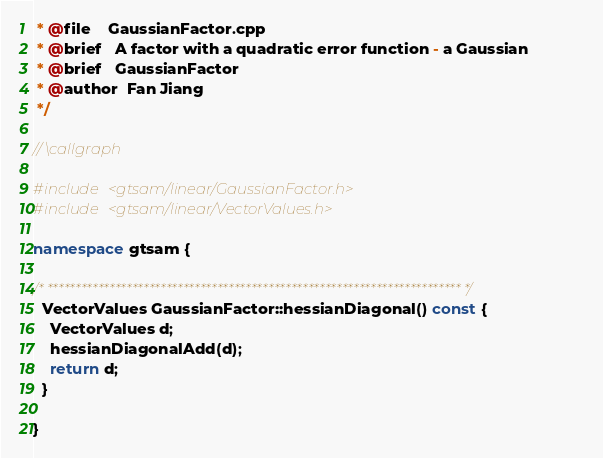Convert code to text. <code><loc_0><loc_0><loc_500><loc_500><_C++_> * @file    GaussianFactor.cpp
 * @brief   A factor with a quadratic error function - a Gaussian
 * @brief   GaussianFactor
 * @author  Fan Jiang
 */

// \callgraph

#include <gtsam/linear/GaussianFactor.h>
#include <gtsam/linear/VectorValues.h>

namespace gtsam {

/* ************************************************************************* */
  VectorValues GaussianFactor::hessianDiagonal() const {
    VectorValues d;
    hessianDiagonalAdd(d);
    return d;
  }

}
</code> 